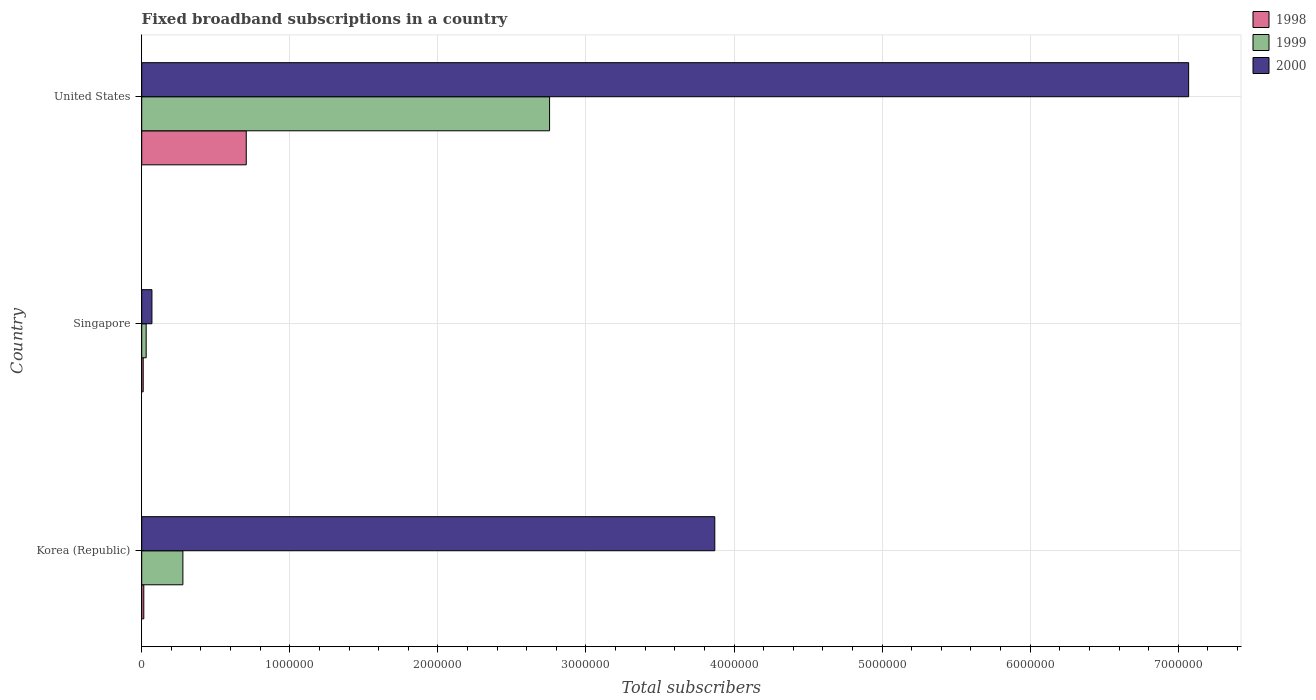Are the number of bars per tick equal to the number of legend labels?
Your response must be concise. Yes. How many bars are there on the 3rd tick from the top?
Your response must be concise. 3. How many bars are there on the 2nd tick from the bottom?
Give a very brief answer. 3. What is the label of the 2nd group of bars from the top?
Give a very brief answer. Singapore. In how many cases, is the number of bars for a given country not equal to the number of legend labels?
Provide a short and direct response. 0. What is the number of broadband subscriptions in 2000 in Korea (Republic)?
Your answer should be very brief. 3.87e+06. Across all countries, what is the maximum number of broadband subscriptions in 1999?
Offer a very short reply. 2.75e+06. In which country was the number of broadband subscriptions in 1998 minimum?
Your response must be concise. Singapore. What is the total number of broadband subscriptions in 1999 in the graph?
Provide a short and direct response. 3.06e+06. What is the difference between the number of broadband subscriptions in 1999 in Korea (Republic) and that in Singapore?
Make the answer very short. 2.48e+05. What is the difference between the number of broadband subscriptions in 1999 in Singapore and the number of broadband subscriptions in 2000 in Korea (Republic)?
Make the answer very short. -3.84e+06. What is the average number of broadband subscriptions in 1999 per country?
Give a very brief answer. 1.02e+06. What is the difference between the number of broadband subscriptions in 1999 and number of broadband subscriptions in 1998 in United States?
Make the answer very short. 2.05e+06. What is the ratio of the number of broadband subscriptions in 1998 in Singapore to that in United States?
Provide a short and direct response. 0.01. Is the number of broadband subscriptions in 2000 in Korea (Republic) less than that in Singapore?
Give a very brief answer. No. Is the difference between the number of broadband subscriptions in 1999 in Korea (Republic) and Singapore greater than the difference between the number of broadband subscriptions in 1998 in Korea (Republic) and Singapore?
Provide a succinct answer. Yes. What is the difference between the highest and the second highest number of broadband subscriptions in 1999?
Provide a short and direct response. 2.48e+06. What is the difference between the highest and the lowest number of broadband subscriptions in 1998?
Your response must be concise. 6.96e+05. What does the 2nd bar from the bottom in Korea (Republic) represents?
Offer a terse response. 1999. Is it the case that in every country, the sum of the number of broadband subscriptions in 2000 and number of broadband subscriptions in 1999 is greater than the number of broadband subscriptions in 1998?
Provide a succinct answer. Yes. What is the difference between two consecutive major ticks on the X-axis?
Your answer should be very brief. 1.00e+06. Does the graph contain any zero values?
Your answer should be compact. No. Does the graph contain grids?
Offer a terse response. Yes. How many legend labels are there?
Offer a terse response. 3. How are the legend labels stacked?
Keep it short and to the point. Vertical. What is the title of the graph?
Offer a terse response. Fixed broadband subscriptions in a country. What is the label or title of the X-axis?
Offer a very short reply. Total subscribers. What is the label or title of the Y-axis?
Ensure brevity in your answer.  Country. What is the Total subscribers of 1998 in Korea (Republic)?
Make the answer very short. 1.40e+04. What is the Total subscribers in 1999 in Korea (Republic)?
Your answer should be compact. 2.78e+05. What is the Total subscribers of 2000 in Korea (Republic)?
Ensure brevity in your answer.  3.87e+06. What is the Total subscribers in 1998 in Singapore?
Offer a terse response. 10000. What is the Total subscribers in 1999 in Singapore?
Give a very brief answer. 3.00e+04. What is the Total subscribers of 2000 in Singapore?
Offer a terse response. 6.90e+04. What is the Total subscribers of 1998 in United States?
Make the answer very short. 7.06e+05. What is the Total subscribers of 1999 in United States?
Your answer should be compact. 2.75e+06. What is the Total subscribers in 2000 in United States?
Your answer should be compact. 7.07e+06. Across all countries, what is the maximum Total subscribers of 1998?
Keep it short and to the point. 7.06e+05. Across all countries, what is the maximum Total subscribers in 1999?
Offer a terse response. 2.75e+06. Across all countries, what is the maximum Total subscribers in 2000?
Your response must be concise. 7.07e+06. Across all countries, what is the minimum Total subscribers of 1999?
Offer a very short reply. 3.00e+04. Across all countries, what is the minimum Total subscribers of 2000?
Offer a very short reply. 6.90e+04. What is the total Total subscribers of 1998 in the graph?
Ensure brevity in your answer.  7.30e+05. What is the total Total subscribers of 1999 in the graph?
Offer a very short reply. 3.06e+06. What is the total Total subscribers of 2000 in the graph?
Provide a short and direct response. 1.10e+07. What is the difference between the Total subscribers in 1998 in Korea (Republic) and that in Singapore?
Offer a very short reply. 4000. What is the difference between the Total subscribers of 1999 in Korea (Republic) and that in Singapore?
Offer a very short reply. 2.48e+05. What is the difference between the Total subscribers in 2000 in Korea (Republic) and that in Singapore?
Your answer should be compact. 3.80e+06. What is the difference between the Total subscribers in 1998 in Korea (Republic) and that in United States?
Provide a short and direct response. -6.92e+05. What is the difference between the Total subscribers in 1999 in Korea (Republic) and that in United States?
Your answer should be very brief. -2.48e+06. What is the difference between the Total subscribers in 2000 in Korea (Republic) and that in United States?
Make the answer very short. -3.20e+06. What is the difference between the Total subscribers of 1998 in Singapore and that in United States?
Your answer should be compact. -6.96e+05. What is the difference between the Total subscribers of 1999 in Singapore and that in United States?
Your response must be concise. -2.72e+06. What is the difference between the Total subscribers in 2000 in Singapore and that in United States?
Keep it short and to the point. -7.00e+06. What is the difference between the Total subscribers of 1998 in Korea (Republic) and the Total subscribers of 1999 in Singapore?
Offer a very short reply. -1.60e+04. What is the difference between the Total subscribers in 1998 in Korea (Republic) and the Total subscribers in 2000 in Singapore?
Provide a short and direct response. -5.50e+04. What is the difference between the Total subscribers in 1999 in Korea (Republic) and the Total subscribers in 2000 in Singapore?
Keep it short and to the point. 2.09e+05. What is the difference between the Total subscribers of 1998 in Korea (Republic) and the Total subscribers of 1999 in United States?
Keep it short and to the point. -2.74e+06. What is the difference between the Total subscribers in 1998 in Korea (Republic) and the Total subscribers in 2000 in United States?
Keep it short and to the point. -7.06e+06. What is the difference between the Total subscribers of 1999 in Korea (Republic) and the Total subscribers of 2000 in United States?
Your answer should be very brief. -6.79e+06. What is the difference between the Total subscribers of 1998 in Singapore and the Total subscribers of 1999 in United States?
Provide a succinct answer. -2.74e+06. What is the difference between the Total subscribers in 1998 in Singapore and the Total subscribers in 2000 in United States?
Keep it short and to the point. -7.06e+06. What is the difference between the Total subscribers of 1999 in Singapore and the Total subscribers of 2000 in United States?
Your answer should be compact. -7.04e+06. What is the average Total subscribers in 1998 per country?
Your response must be concise. 2.43e+05. What is the average Total subscribers of 1999 per country?
Make the answer very short. 1.02e+06. What is the average Total subscribers of 2000 per country?
Your answer should be very brief. 3.67e+06. What is the difference between the Total subscribers of 1998 and Total subscribers of 1999 in Korea (Republic)?
Your answer should be very brief. -2.64e+05. What is the difference between the Total subscribers in 1998 and Total subscribers in 2000 in Korea (Republic)?
Your answer should be very brief. -3.86e+06. What is the difference between the Total subscribers in 1999 and Total subscribers in 2000 in Korea (Republic)?
Provide a succinct answer. -3.59e+06. What is the difference between the Total subscribers in 1998 and Total subscribers in 1999 in Singapore?
Your answer should be compact. -2.00e+04. What is the difference between the Total subscribers in 1998 and Total subscribers in 2000 in Singapore?
Make the answer very short. -5.90e+04. What is the difference between the Total subscribers in 1999 and Total subscribers in 2000 in Singapore?
Offer a very short reply. -3.90e+04. What is the difference between the Total subscribers of 1998 and Total subscribers of 1999 in United States?
Provide a succinct answer. -2.05e+06. What is the difference between the Total subscribers in 1998 and Total subscribers in 2000 in United States?
Your response must be concise. -6.36e+06. What is the difference between the Total subscribers of 1999 and Total subscribers of 2000 in United States?
Offer a terse response. -4.32e+06. What is the ratio of the Total subscribers of 1999 in Korea (Republic) to that in Singapore?
Provide a succinct answer. 9.27. What is the ratio of the Total subscribers in 2000 in Korea (Republic) to that in Singapore?
Offer a terse response. 56.09. What is the ratio of the Total subscribers in 1998 in Korea (Republic) to that in United States?
Your answer should be very brief. 0.02. What is the ratio of the Total subscribers in 1999 in Korea (Republic) to that in United States?
Provide a short and direct response. 0.1. What is the ratio of the Total subscribers of 2000 in Korea (Republic) to that in United States?
Your answer should be very brief. 0.55. What is the ratio of the Total subscribers in 1998 in Singapore to that in United States?
Your response must be concise. 0.01. What is the ratio of the Total subscribers of 1999 in Singapore to that in United States?
Make the answer very short. 0.01. What is the ratio of the Total subscribers in 2000 in Singapore to that in United States?
Your answer should be very brief. 0.01. What is the difference between the highest and the second highest Total subscribers of 1998?
Your answer should be very brief. 6.92e+05. What is the difference between the highest and the second highest Total subscribers in 1999?
Offer a terse response. 2.48e+06. What is the difference between the highest and the second highest Total subscribers in 2000?
Provide a short and direct response. 3.20e+06. What is the difference between the highest and the lowest Total subscribers of 1998?
Your answer should be very brief. 6.96e+05. What is the difference between the highest and the lowest Total subscribers in 1999?
Offer a very short reply. 2.72e+06. What is the difference between the highest and the lowest Total subscribers in 2000?
Give a very brief answer. 7.00e+06. 